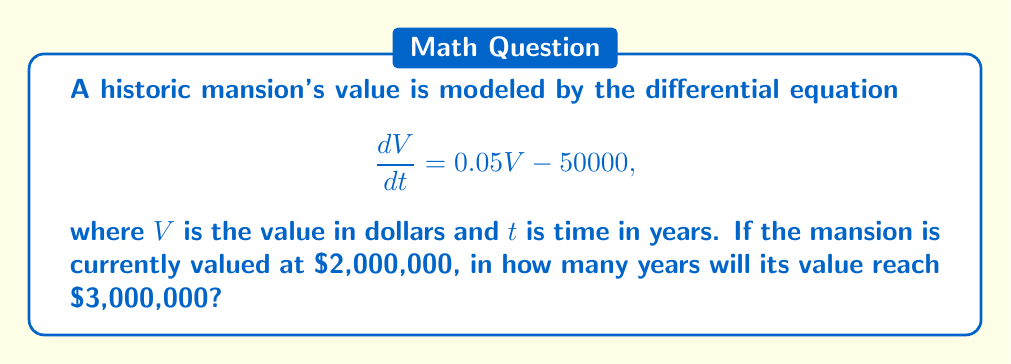Could you help me with this problem? 1) We start with the given differential equation:
   $$\frac{dV}{dt} = 0.05V - 50000$$

2) This is a linear first-order differential equation. The solution is:
   $$V(t) = 1000000 + Ce^{0.05t}$$
   where $C$ is a constant determined by the initial condition.

3) Given the initial condition $V(0) = 2000000$, we can find $C$:
   $$2000000 = 1000000 + C$$
   $$C = 1000000$$

4) So our particular solution is:
   $$V(t) = 1000000 + 1000000e^{0.05t}$$

5) We want to find $t$ when $V(t) = 3000000$:
   $$3000000 = 1000000 + 1000000e^{0.05t}$$

6) Solving for $t$:
   $$2000000 = 1000000e^{0.05t}$$
   $$2 = e^{0.05t}$$
   $$\ln(2) = 0.05t$$
   $$t = \frac{\ln(2)}{0.05} \approx 13.86$$

7) Therefore, it will take approximately 13.86 years for the mansion's value to reach $3,000,000.
Answer: 13.86 years 